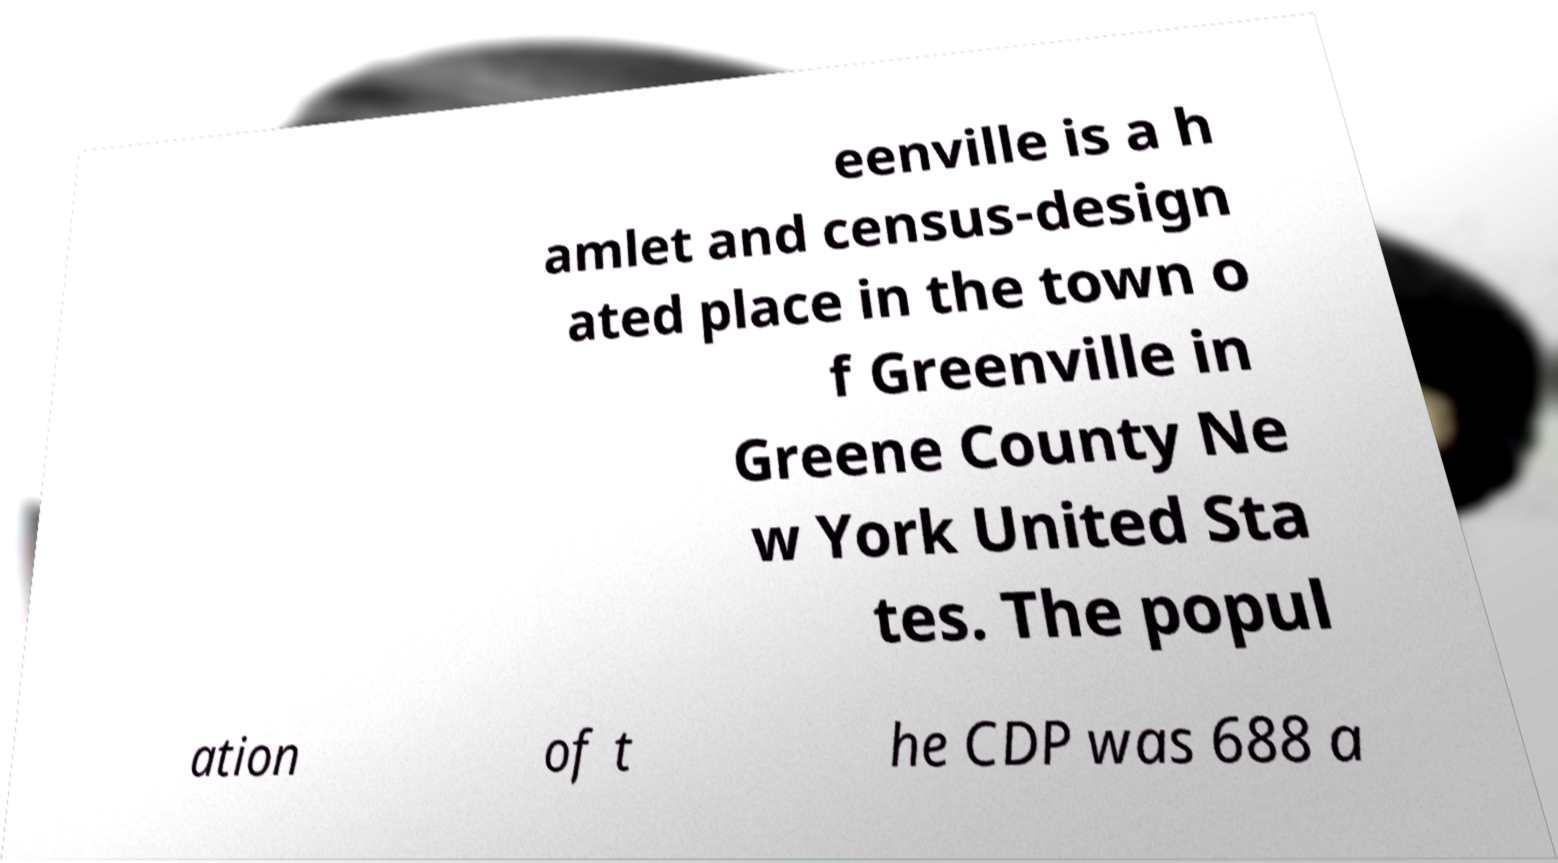Could you assist in decoding the text presented in this image and type it out clearly? eenville is a h amlet and census-design ated place in the town o f Greenville in Greene County Ne w York United Sta tes. The popul ation of t he CDP was 688 a 